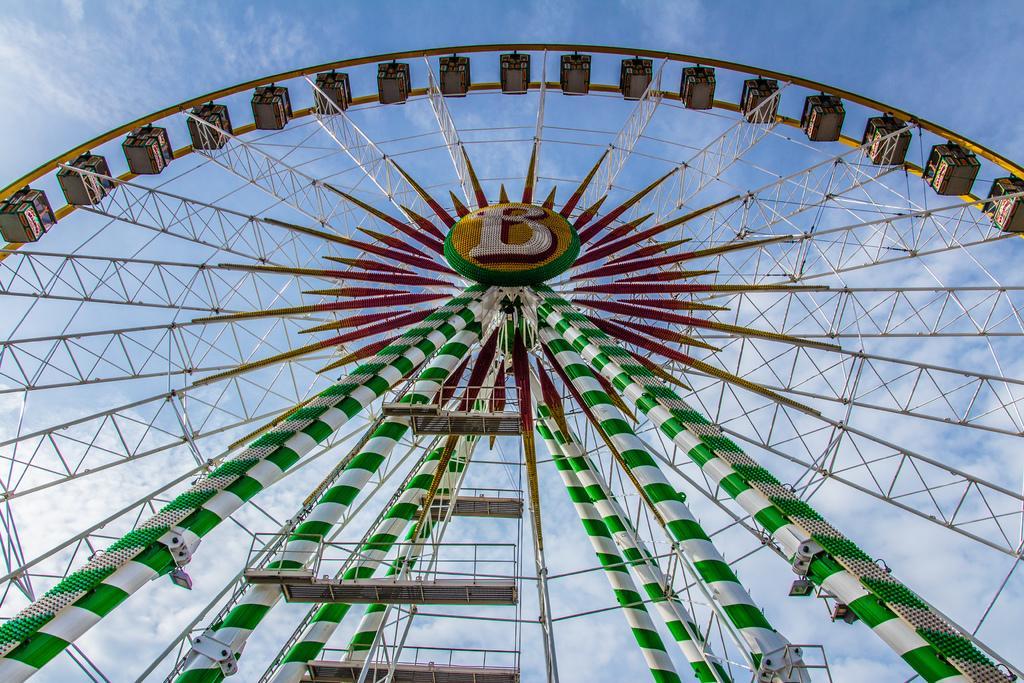Describe this image in one or two sentences. In this image, we can see there is a giant wheel. In the background, there are clouds in the blue sky. 